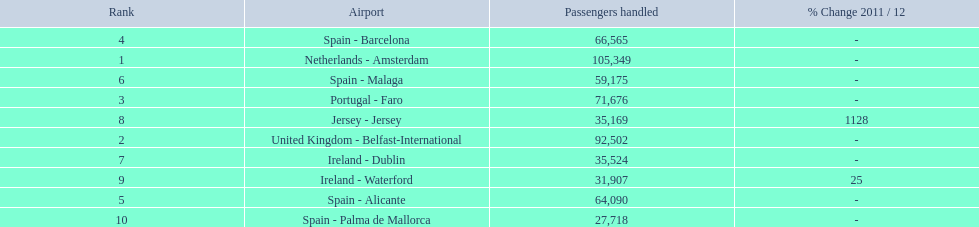What are all of the destinations out of the london southend airport? Netherlands - Amsterdam, United Kingdom - Belfast-International, Portugal - Faro, Spain - Barcelona, Spain - Alicante, Spain - Malaga, Ireland - Dublin, Jersey - Jersey, Ireland - Waterford, Spain - Palma de Mallorca. How many passengers has each destination handled? 105,349, 92,502, 71,676, 66,565, 64,090, 59,175, 35,524, 35,169, 31,907, 27,718. And of those, which airport handled the fewest passengers? Spain - Palma de Mallorca. 